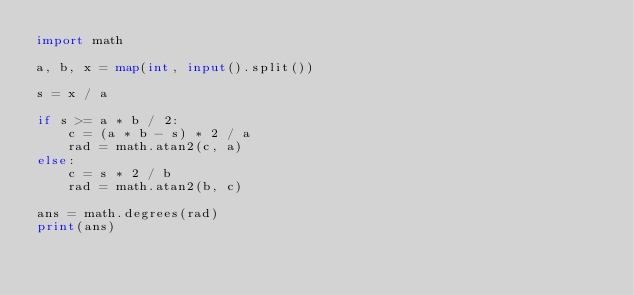Convert code to text. <code><loc_0><loc_0><loc_500><loc_500><_Python_>import math

a, b, x = map(int, input().split())

s = x / a

if s >= a * b / 2:
    c = (a * b - s) * 2 / a
    rad = math.atan2(c, a)
else:
    c = s * 2 / b
    rad = math.atan2(b, c)

ans = math.degrees(rad)
print(ans)
</code> 